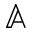Convert formula to latex. <formula><loc_0><loc_0><loc_500><loc_500>\mathbb { A }</formula> 